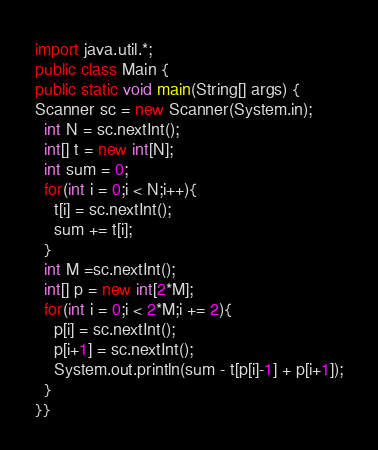<code> <loc_0><loc_0><loc_500><loc_500><_Java_>import java.util.*;
public class Main {
public static void main(String[] args) {
Scanner sc = new Scanner(System.in);
  int N = sc.nextInt();
  int[] t = new int[N];
  int sum = 0;
  for(int i = 0;i < N;i++){
    t[i] = sc.nextInt();
    sum += t[i];
  }
  int M =sc.nextInt();
  int[] p = new int[2*M];
  for(int i = 0;i < 2*M;i += 2){
    p[i] = sc.nextInt();
    p[i+1] = sc.nextInt();
    System.out.println(sum - t[p[i]-1] + p[i+1]);
  }
}}
</code> 